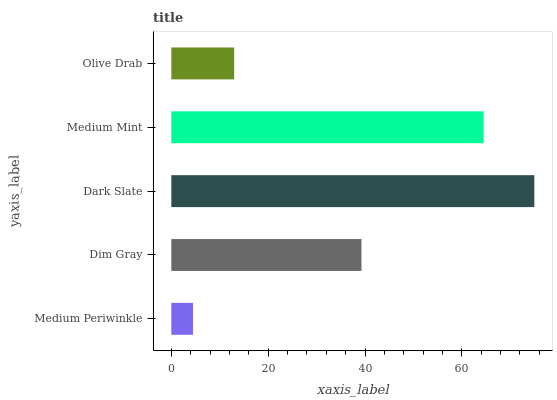Is Medium Periwinkle the minimum?
Answer yes or no. Yes. Is Dark Slate the maximum?
Answer yes or no. Yes. Is Dim Gray the minimum?
Answer yes or no. No. Is Dim Gray the maximum?
Answer yes or no. No. Is Dim Gray greater than Medium Periwinkle?
Answer yes or no. Yes. Is Medium Periwinkle less than Dim Gray?
Answer yes or no. Yes. Is Medium Periwinkle greater than Dim Gray?
Answer yes or no. No. Is Dim Gray less than Medium Periwinkle?
Answer yes or no. No. Is Dim Gray the high median?
Answer yes or no. Yes. Is Dim Gray the low median?
Answer yes or no. Yes. Is Olive Drab the high median?
Answer yes or no. No. Is Medium Mint the low median?
Answer yes or no. No. 